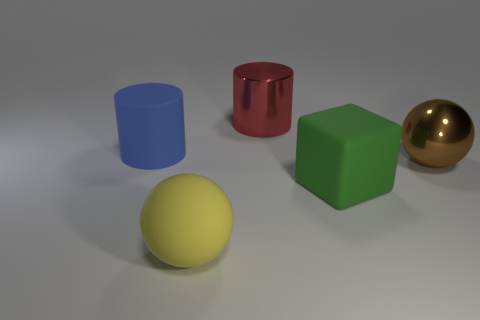Add 1 large shiny spheres. How many objects exist? 6 Subtract all blocks. How many objects are left? 4 Add 1 shiny cylinders. How many shiny cylinders exist? 2 Subtract 1 yellow balls. How many objects are left? 4 Subtract all rubber cubes. Subtract all blue rubber things. How many objects are left? 3 Add 5 brown shiny objects. How many brown shiny objects are left? 6 